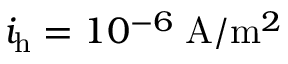Convert formula to latex. <formula><loc_0><loc_0><loc_500><loc_500>i _ { h } = 1 0 ^ { - 6 } \, A / m ^ { 2 }</formula> 